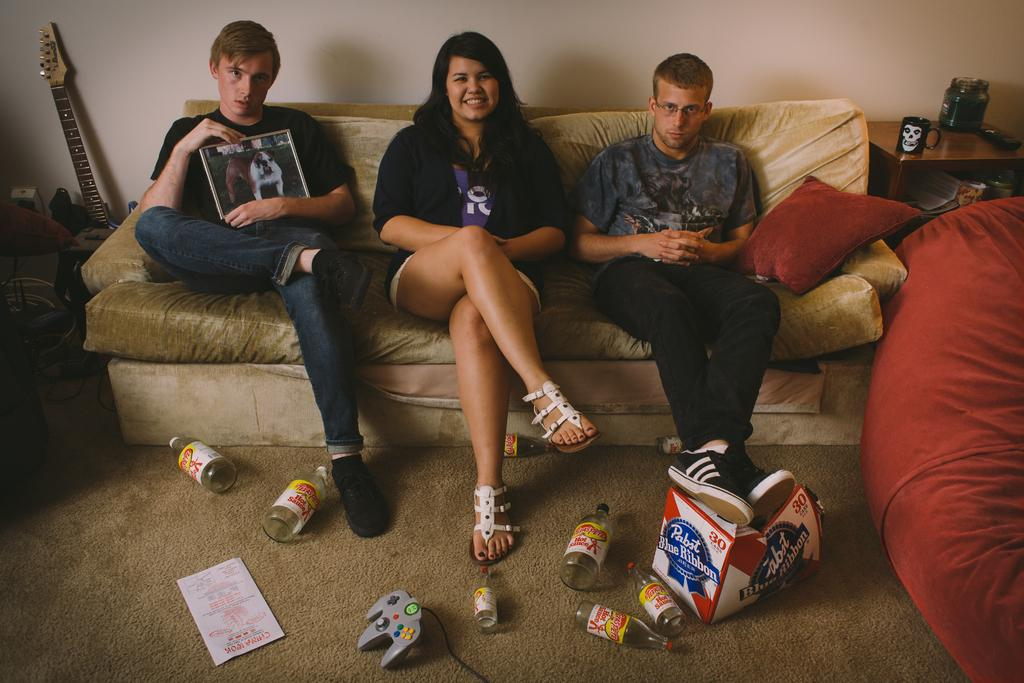<image>
Provide a brief description of the given image. A boy props his feet on a box that reads "Pabst Blue Ribbon." 